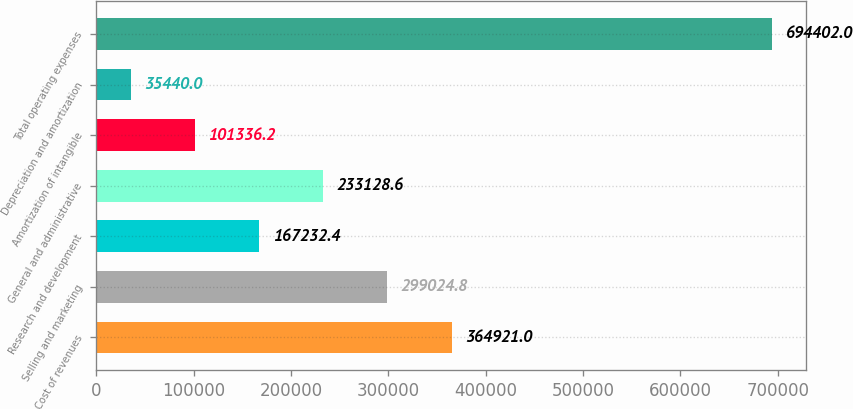Convert chart to OTSL. <chart><loc_0><loc_0><loc_500><loc_500><bar_chart><fcel>Cost of revenues<fcel>Selling and marketing<fcel>Research and development<fcel>General and administrative<fcel>Amortization of intangible<fcel>Depreciation and amortization<fcel>Total operating expenses<nl><fcel>364921<fcel>299025<fcel>167232<fcel>233129<fcel>101336<fcel>35440<fcel>694402<nl></chart> 